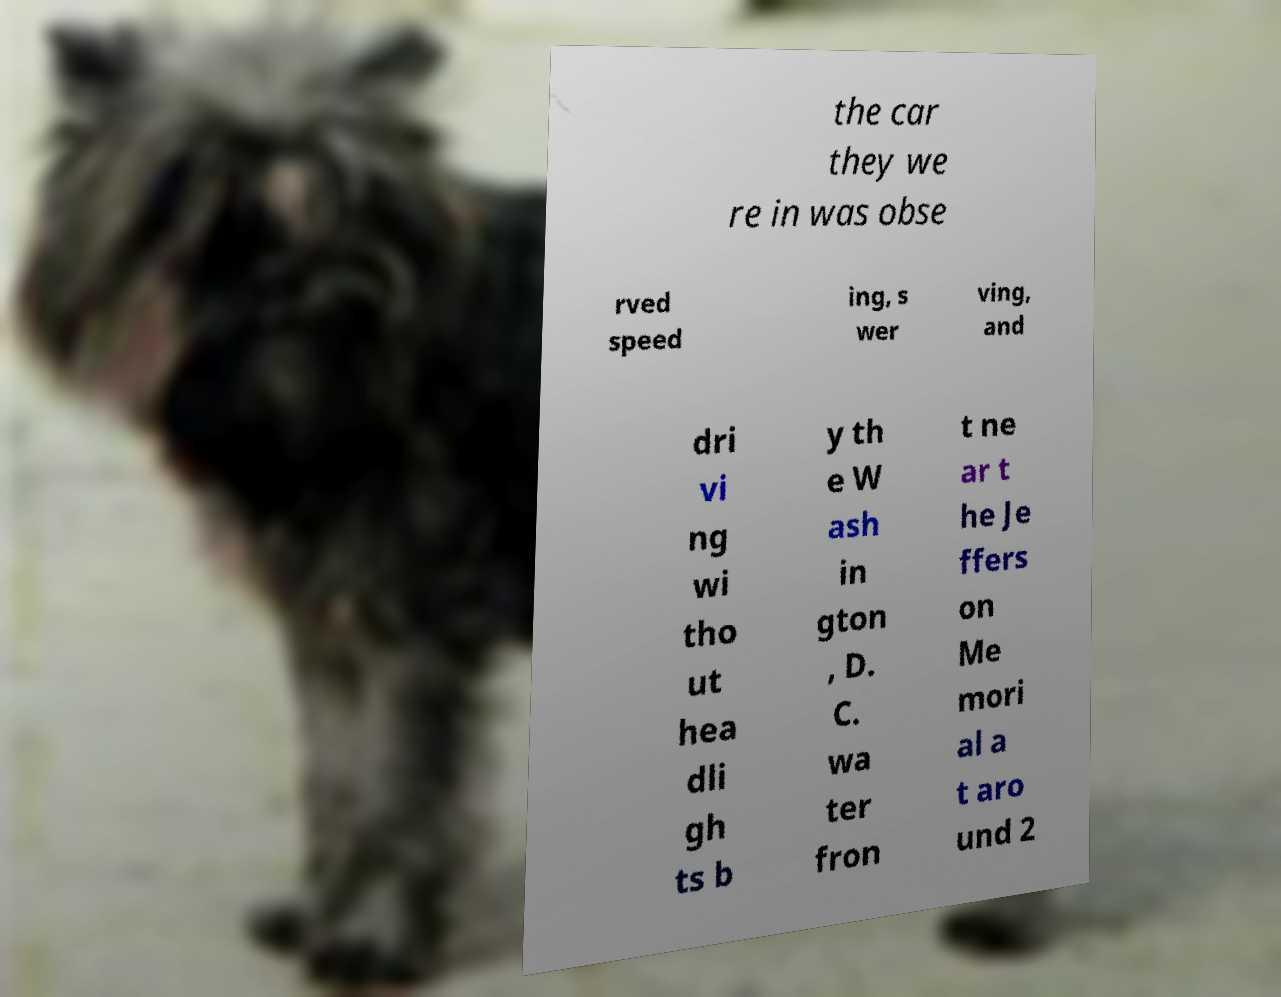Can you read and provide the text displayed in the image?This photo seems to have some interesting text. Can you extract and type it out for me? the car they we re in was obse rved speed ing, s wer ving, and dri vi ng wi tho ut hea dli gh ts b y th e W ash in gton , D. C. wa ter fron t ne ar t he Je ffers on Me mori al a t aro und 2 